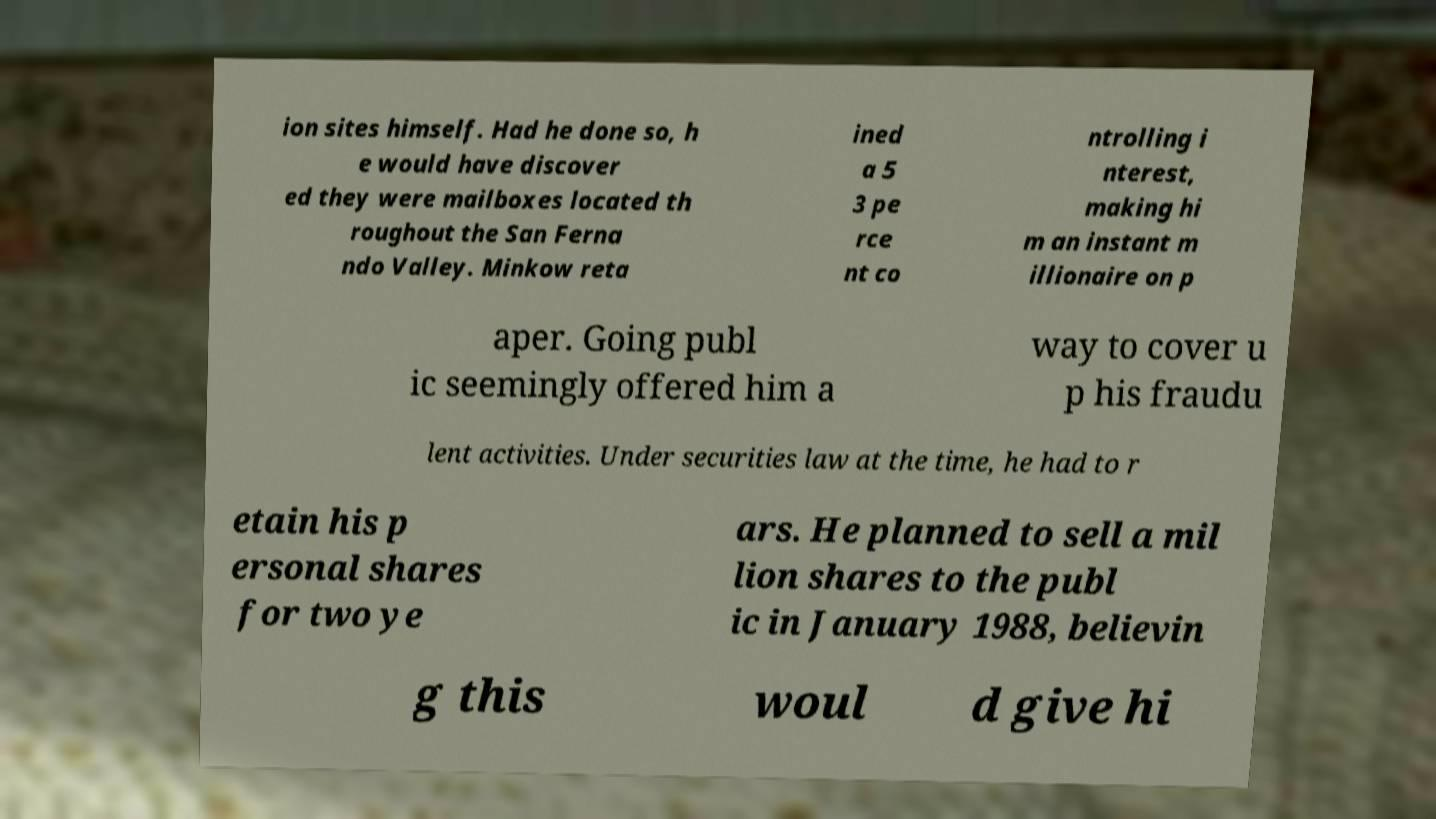Can you accurately transcribe the text from the provided image for me? ion sites himself. Had he done so, h e would have discover ed they were mailboxes located th roughout the San Ferna ndo Valley. Minkow reta ined a 5 3 pe rce nt co ntrolling i nterest, making hi m an instant m illionaire on p aper. Going publ ic seemingly offered him a way to cover u p his fraudu lent activities. Under securities law at the time, he had to r etain his p ersonal shares for two ye ars. He planned to sell a mil lion shares to the publ ic in January 1988, believin g this woul d give hi 